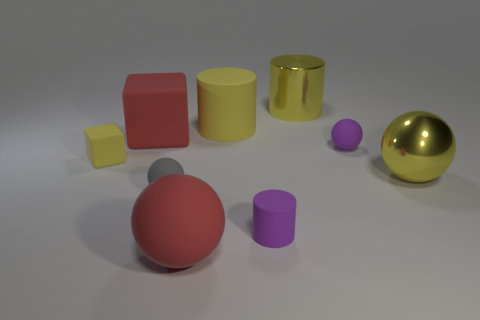What textures can be observed in this scene? The metallic texture is evident on the gold sphere and silver sphere, while the other objects appear to have matte surfaces. 